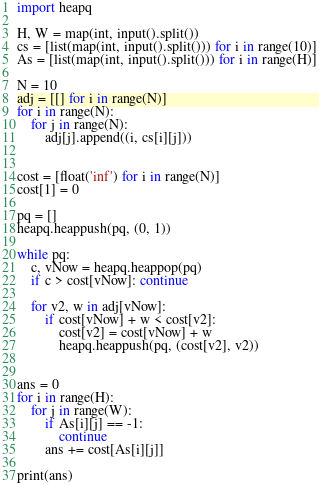<code> <loc_0><loc_0><loc_500><loc_500><_Python_>import heapq

H, W = map(int, input().split())
cs = [list(map(int, input().split())) for i in range(10)]
As = [list(map(int, input().split())) for i in range(H)]

N = 10
adj = [[] for i in range(N)]
for i in range(N):
    for j in range(N):
        adj[j].append((i, cs[i][j]))


cost = [float('inf') for i in range(N)]
cost[1] = 0

pq = []
heapq.heappush(pq, (0, 1))

while pq:
    c, vNow = heapq.heappop(pq)
    if c > cost[vNow]: continue

    for v2, w in adj[vNow]:
        if cost[vNow] + w < cost[v2]:
            cost[v2] = cost[vNow] + w
            heapq.heappush(pq, (cost[v2], v2))


ans = 0
for i in range(H):
    for j in range(W):
        if As[i][j] == -1:
            continue
        ans += cost[As[i][j]]

print(ans)
</code> 